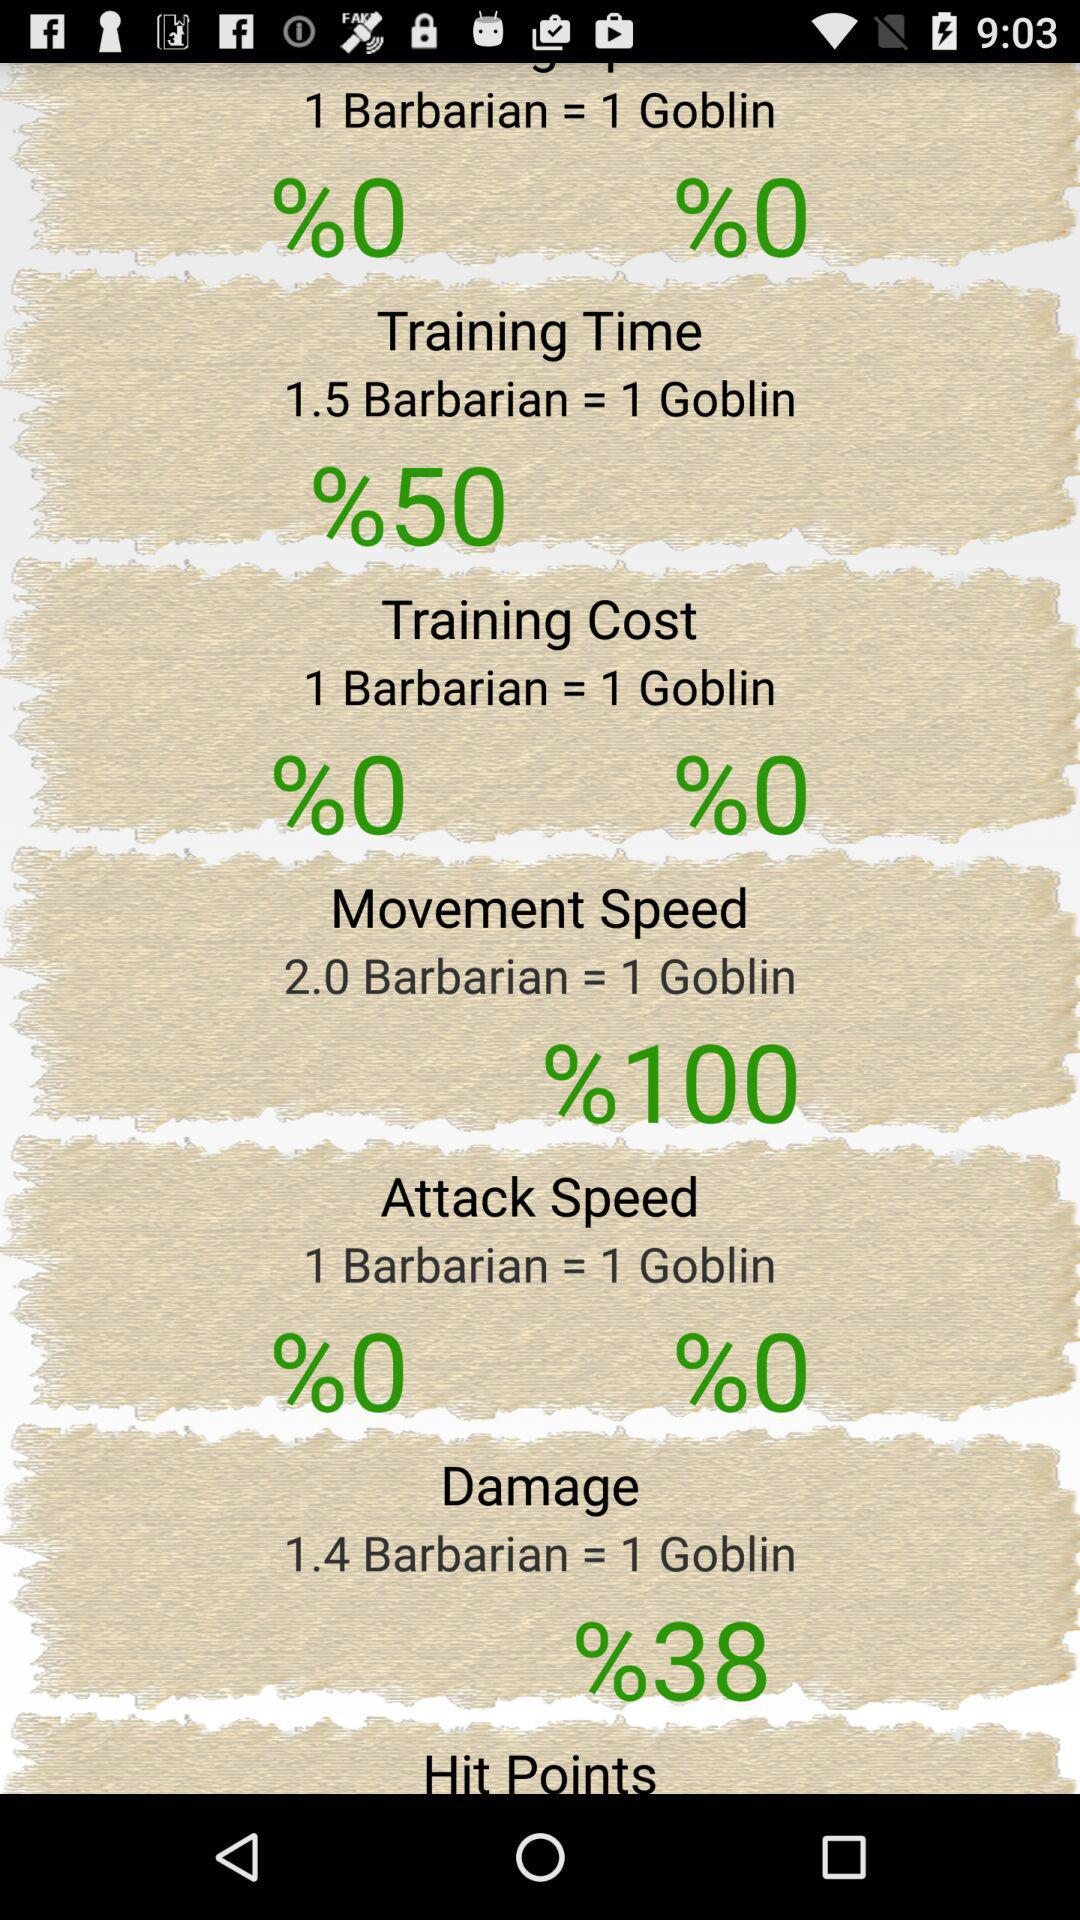How much more damage does a Barbarian do than a Goblin?
Answer the question using a single word or phrase. 38% 